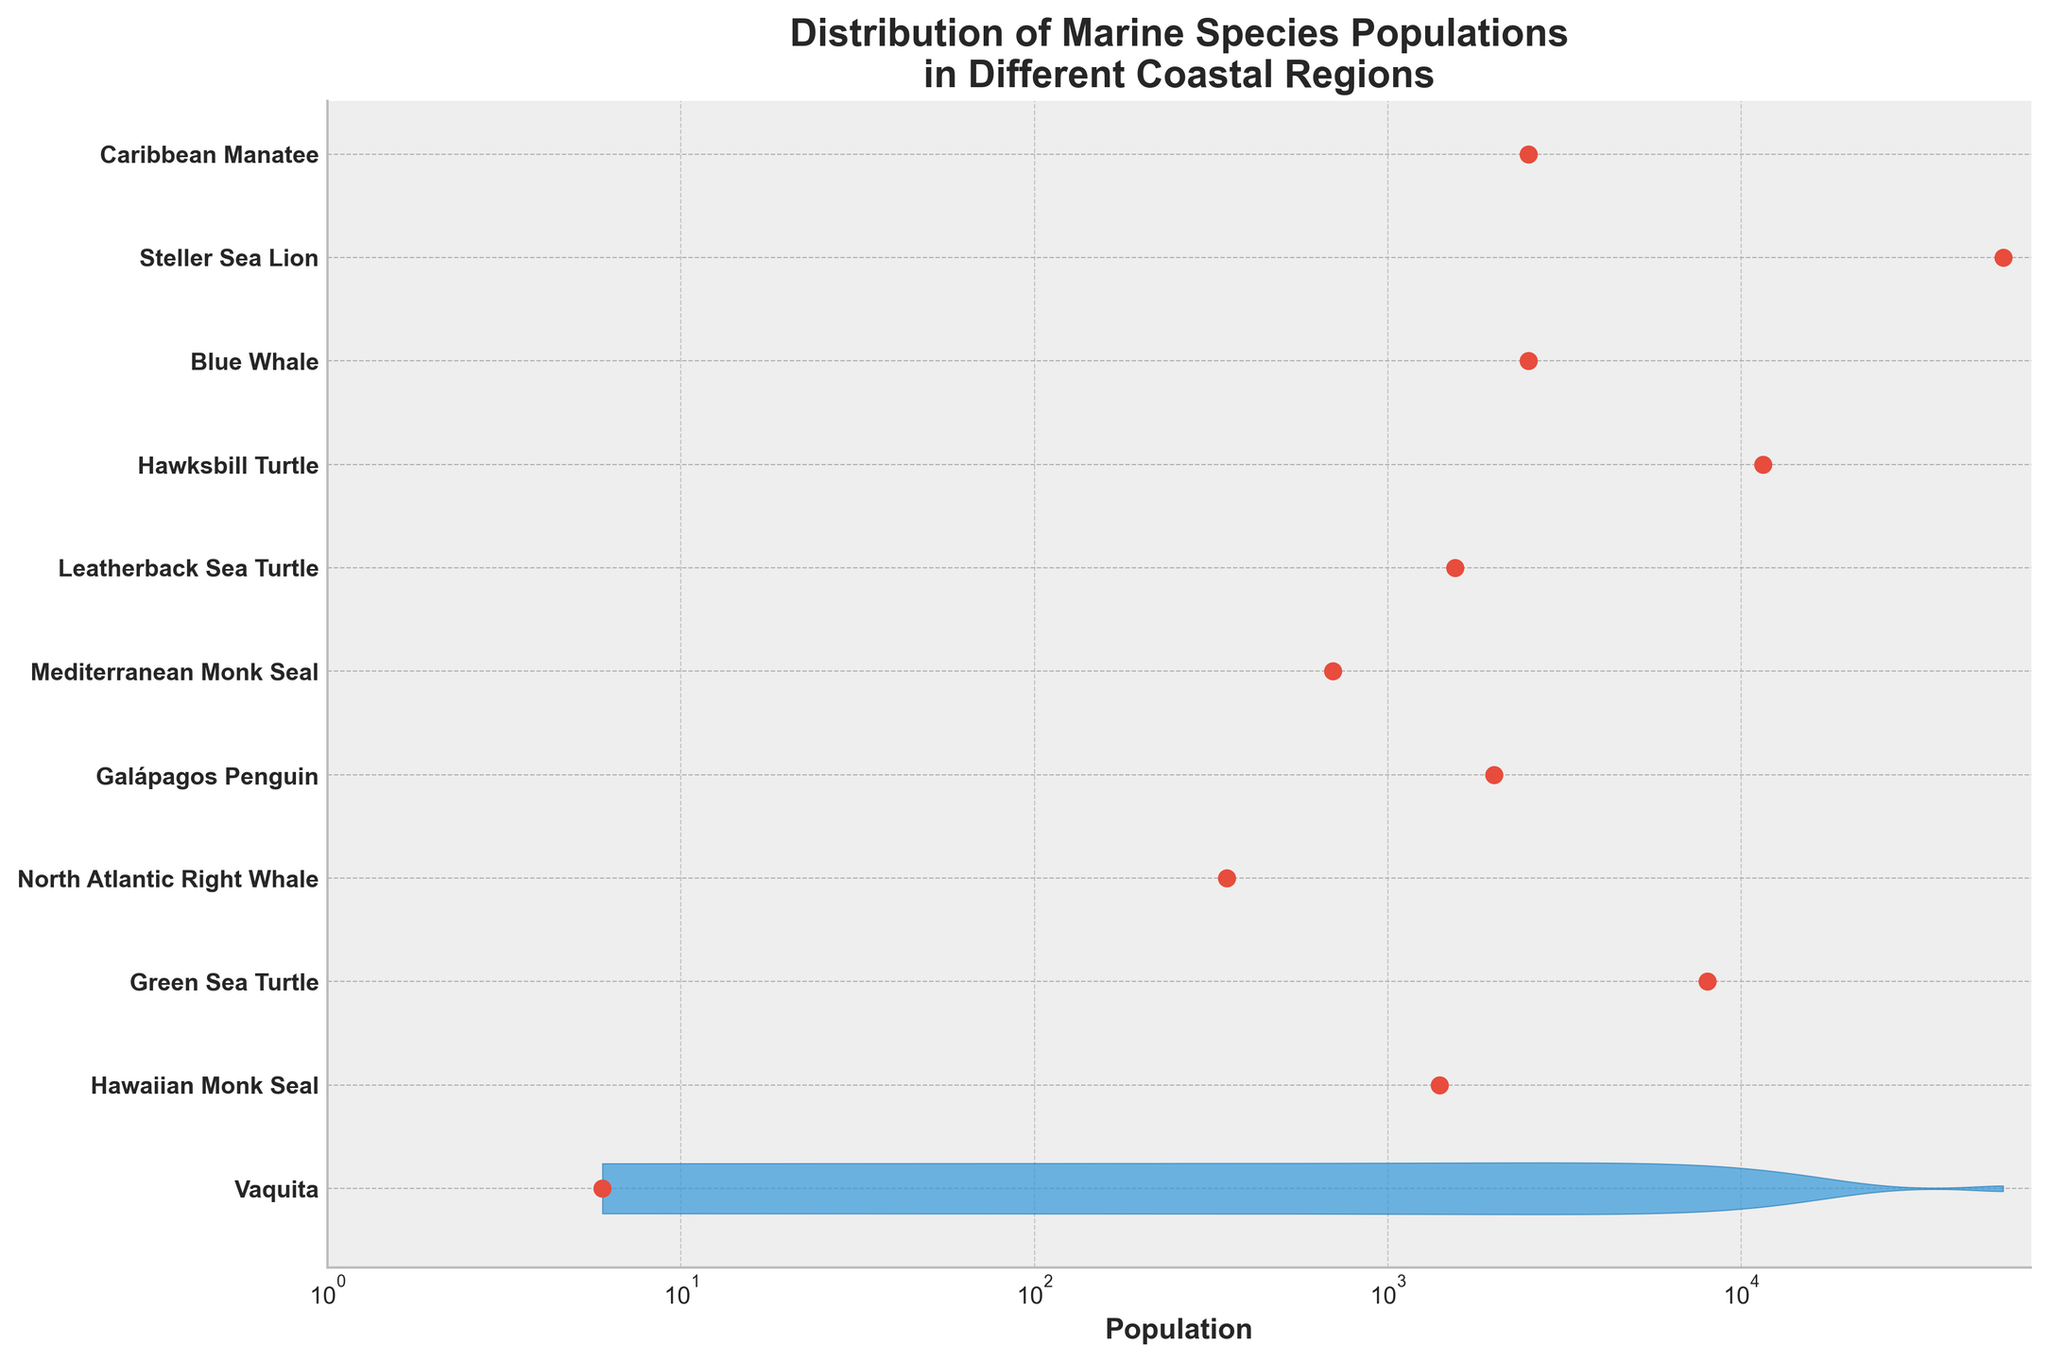What is the title of the plot? The title of the plot is positioned above the figure and is a text that describes what the plot is about. In this case, it tells us that the plot is about the distribution of marine species populations across different coastal regions.
Answer: Distribution of Marine Species Populations in Different Coastal Regions Which species has the lowest population? To find the species with the lowest population, look for the leftmost data point on the x-axis, which is marked by a red dot. This point represents the Vaquita species from the Gulf of California, with a population of just 6.
Answer: Vaquita What is the range of the Blue Whale population? To determine the range of the Blue Whale population, find the violin shape (blue area) corresponding to the Indian Ocean and observe the span of this shape. The Blue Whale's population range is represented mostly around 2500 on the x-axis.
Answer: 2500 How does the population of the North Atlantic Right Whale compare to that of the Mediterranean Monk Seal? Find the North Atlantic Right Whale (Eastern Atlantic Coast) and the Mediterranean Monk Seal (Mediterranean Sea) data points. Notice that the population of the North Atlantic Right Whale is approximately 350, while the Mediterranean Monk Seal's population is about 700, making the seal's population roughly double that of the whale.
Answer: Mediterranean Monk Seal's population is about twice that of the North Atlantic Right Whale's What is the median population of the endangered species listed? To find the median, list the populations in ascending order: 6, 350, 700, 1400, 1550, 2000, 2500, 2500, 8000, 11500, 55000. The median is the middle number in this ordered list, which is 2000.
Answer: 2000 Which species has the most widely distributed population? The violin plot's width at any given point represents population variability. The widest violin plot (blue area) indicates the most widely distributed population. In this case, the Alaskan Coast's Steller Sea Lion, with a population spanning up to 55000, has the most widespread distribution.
Answer: Steller Sea Lion What is the ratio of the population of the most populous species to the least populous species? The most populous species is the Steller Sea Lion (55000), and the least populous is the Vaquita (6). The ratio is 55000 to 6. Calculate the ratio by dividing 55000 by 6, which equals approximately 9167.
Answer: 9167 Which regions have populations below 1000? Look for populations less than 1000 on the x-axis. The species in these regions are the Vaquita (6) from the Gulf of California, and the North Atlantic Right Whale (350) from the Eastern Atlantic Coast, and the Mediterranean Monk Seal (700) from the Mediterranean Sea.
Answer: Gulf of California, Eastern Atlantic Coast, Mediterranean Sea 